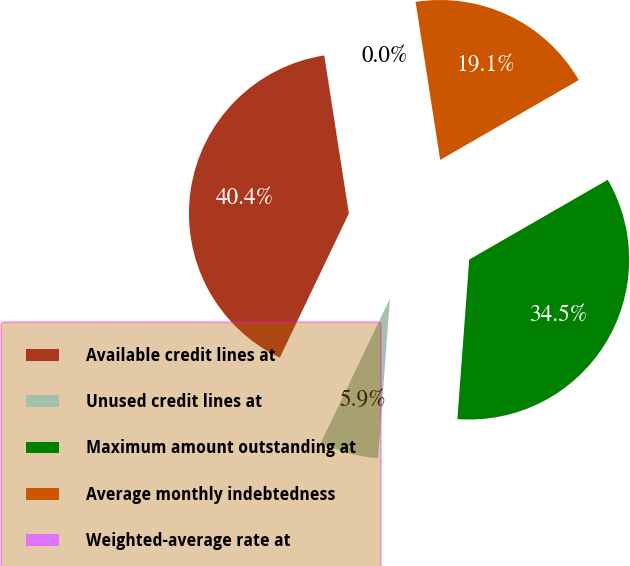Convert chart. <chart><loc_0><loc_0><loc_500><loc_500><pie_chart><fcel>Available credit lines at<fcel>Unused credit lines at<fcel>Maximum amount outstanding at<fcel>Average monthly indebtedness<fcel>Weighted-average rate at<nl><fcel>40.43%<fcel>5.93%<fcel>34.5%<fcel>19.14%<fcel>0.0%<nl></chart> 